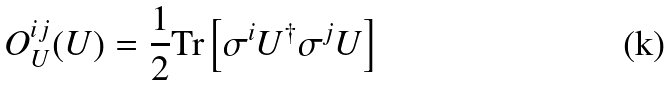<formula> <loc_0><loc_0><loc_500><loc_500>O ^ { i j } _ { U } ( U ) & = \frac { 1 } { 2 } \text {Tr} \left [ \sigma ^ { i } U ^ { \dagger } \sigma ^ { j } U \right ]</formula> 